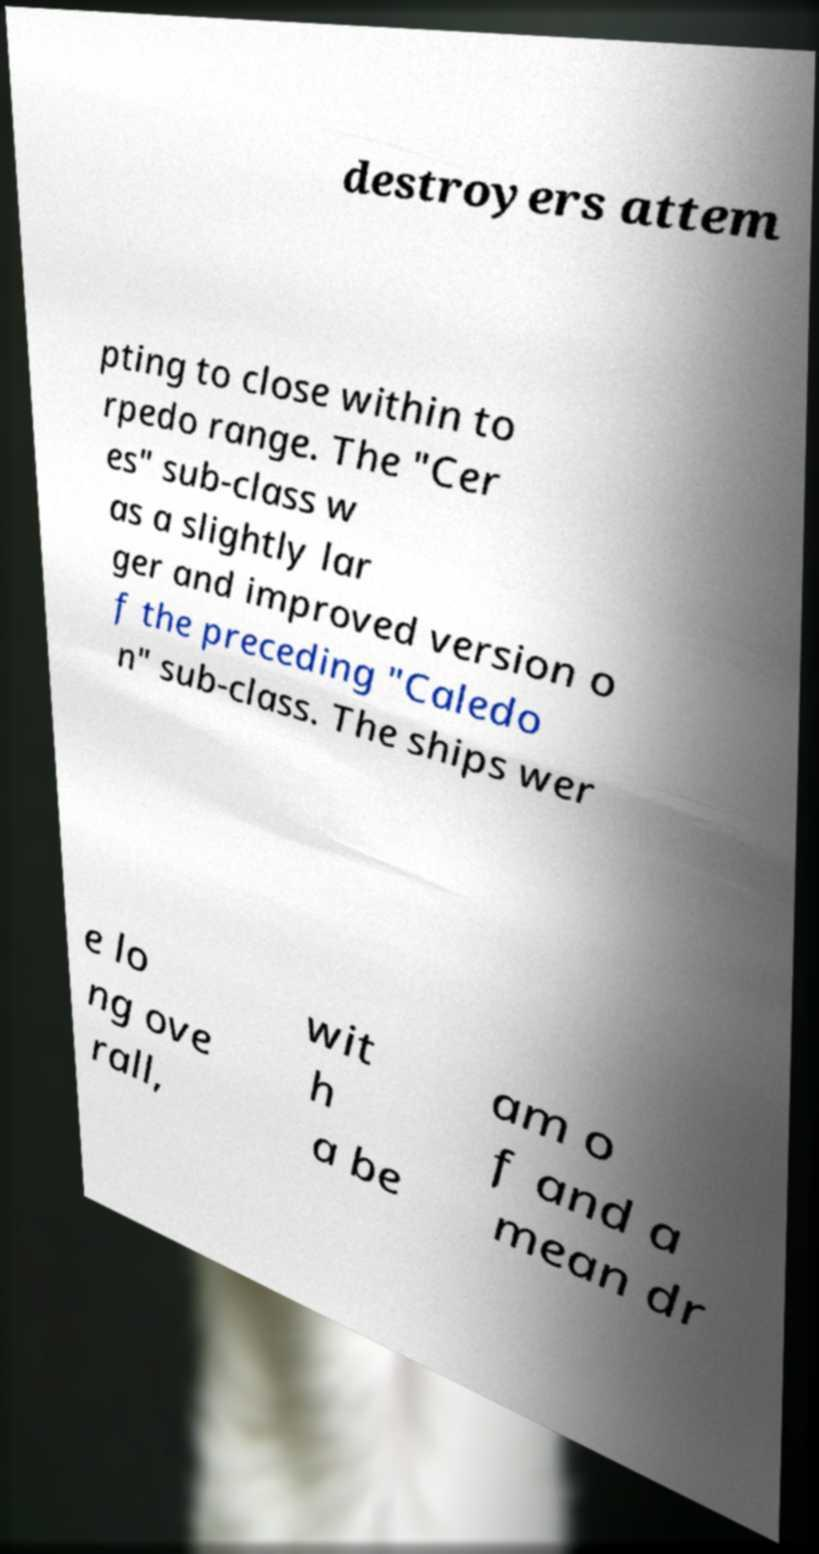There's text embedded in this image that I need extracted. Can you transcribe it verbatim? destroyers attem pting to close within to rpedo range. The "Cer es" sub-class w as a slightly lar ger and improved version o f the preceding "Caledo n" sub-class. The ships wer e lo ng ove rall, wit h a be am o f and a mean dr 